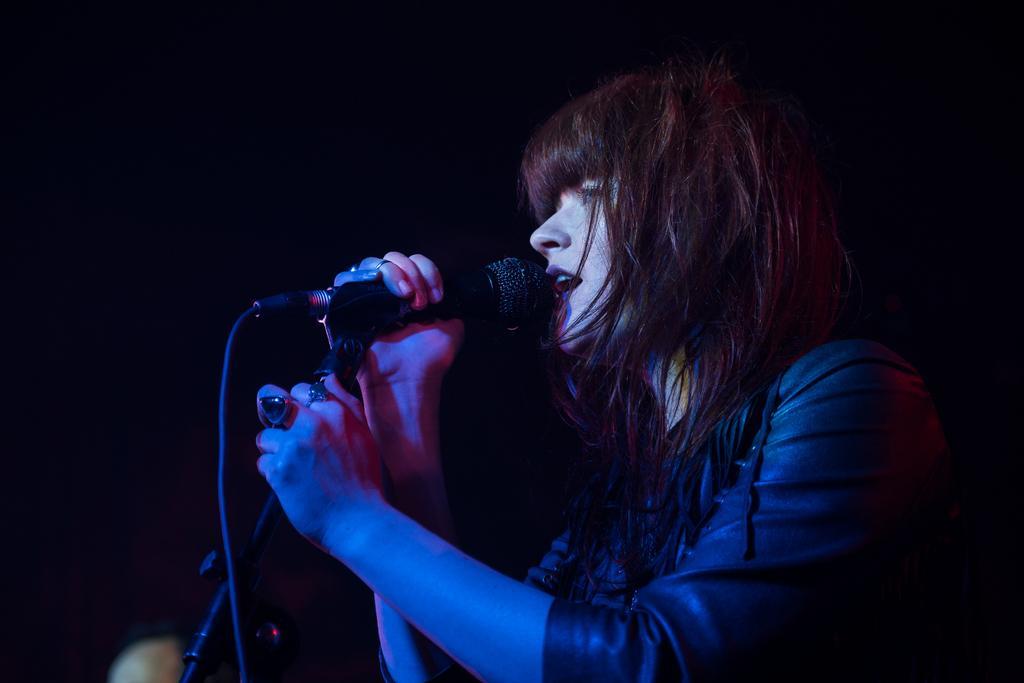Please provide a concise description of this image. In this picture we can see a woman holding a mic with her hands and talking and in the background it is dark. 